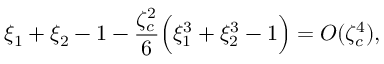<formula> <loc_0><loc_0><loc_500><loc_500>\xi _ { 1 } + \xi _ { 2 } - 1 - \frac { \zeta _ { c } ^ { 2 } } { 6 } \left ( \xi _ { 1 } ^ { 3 } + \xi _ { 2 } ^ { 3 } - 1 \right ) = O ( \zeta _ { c } ^ { 4 } ) ,</formula> 